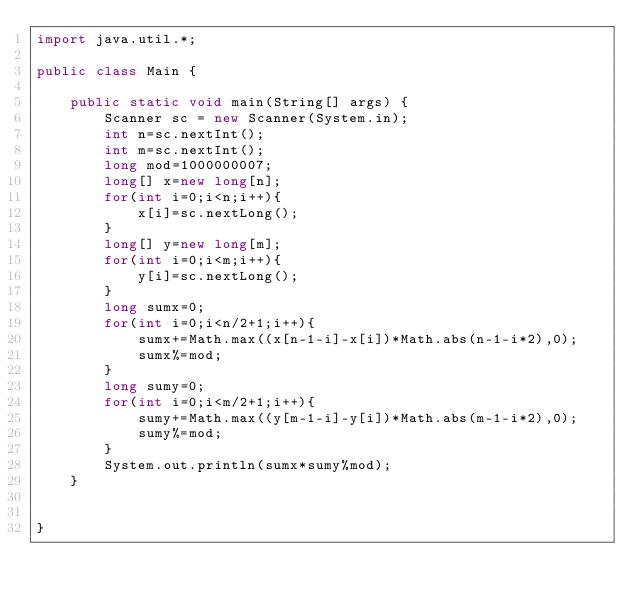<code> <loc_0><loc_0><loc_500><loc_500><_Java_>import java.util.*;
 
public class Main {
 
    public static void main(String[] args) {
        Scanner sc = new Scanner(System.in);
        int n=sc.nextInt();
        int m=sc.nextInt();
        long mod=1000000007;
        long[] x=new long[n];
        for(int i=0;i<n;i++){
            x[i]=sc.nextLong();
        }
        long[] y=new long[m];
        for(int i=0;i<m;i++){
            y[i]=sc.nextLong();
        }
        long sumx=0;
        for(int i=0;i<n/2+1;i++){
            sumx+=Math.max((x[n-1-i]-x[i])*Math.abs(n-1-i*2),0);
            sumx%=mod;
        }
        long sumy=0;
        for(int i=0;i<m/2+1;i++){
            sumy+=Math.max((y[m-1-i]-y[i])*Math.abs(m-1-i*2),0);
            sumy%=mod;
        }
        System.out.println(sumx*sumy%mod);
    }
 
    
}</code> 